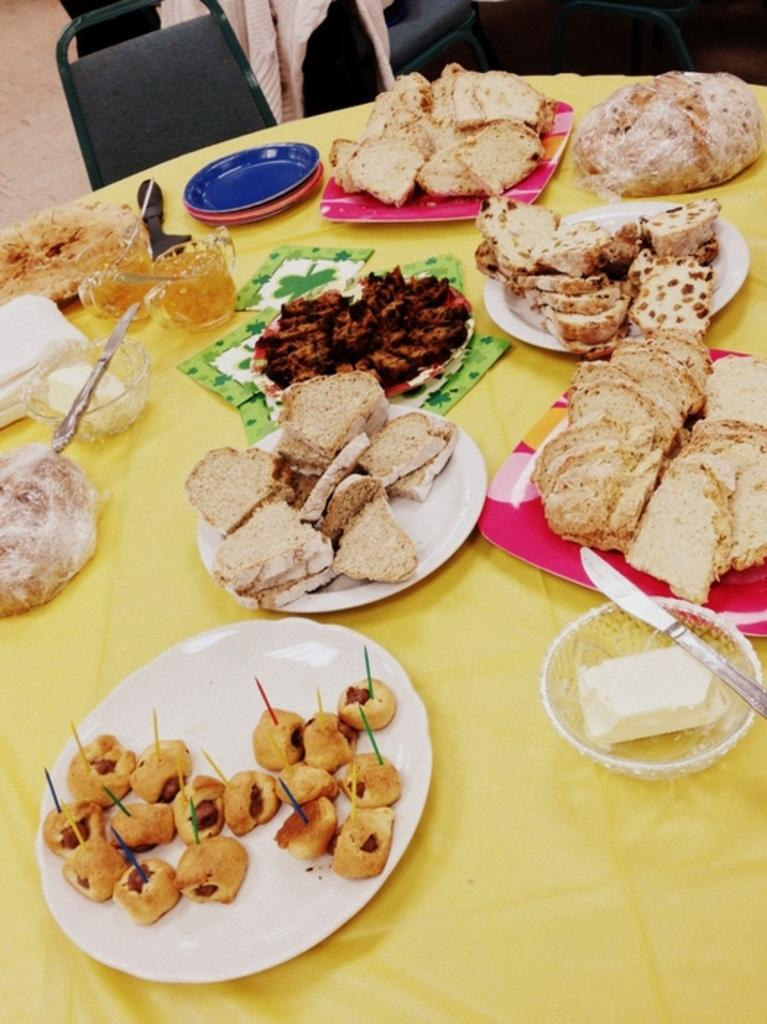What type of furniture is present in the image? There is a table in the image. What items can be seen on the table? There are plates, bowls, cups, tissue papers, a knife, and food items on the table. Are there any seating options visible in the image? Yes, there are chairs visible at the top of the image. What type of gun is visible on the table in the image? There is no gun present in the image; the items on the table include plates, bowls, cups, tissue papers, a knife, and food items. Can you tell me how many marbles are on the table in the image? There are no marbles present in the image; the items on the table include plates, bowls, cups, tissue papers, a knife, and food items. 